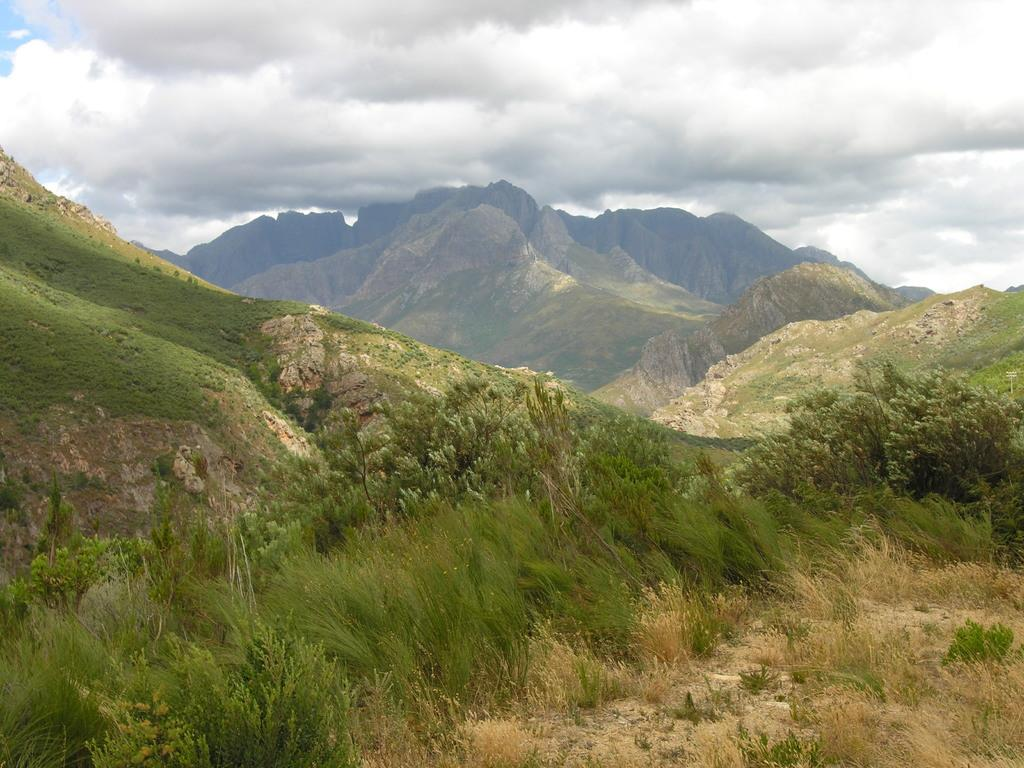What type of natural landscape is depicted in the image? The image features mountains. What type of vegetation can be seen in the image? There is grass and trees visible in the image. What is visible in the sky in the image? There are clouds in the sky in the image. What type of lettuce is growing on the mountains in the image? There is no lettuce visible in the image; the vegetation consists of grass and trees. 